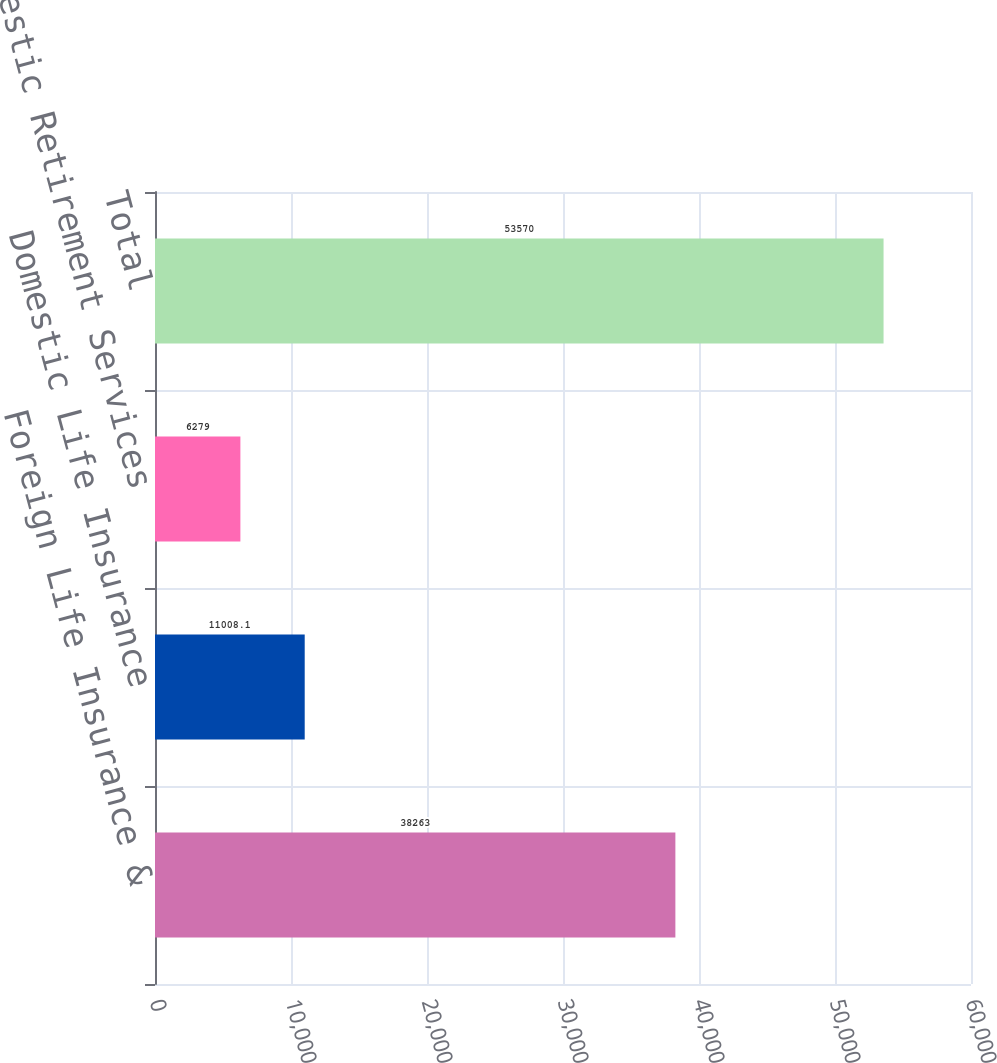Convert chart to OTSL. <chart><loc_0><loc_0><loc_500><loc_500><bar_chart><fcel>Foreign Life Insurance &<fcel>Domestic Life Insurance<fcel>Domestic Retirement Services<fcel>Total<nl><fcel>38263<fcel>11008.1<fcel>6279<fcel>53570<nl></chart> 